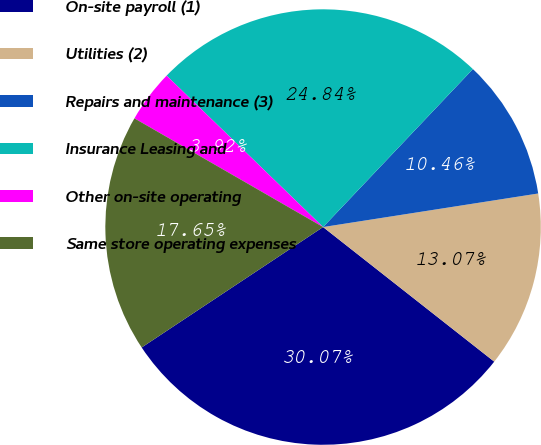Convert chart. <chart><loc_0><loc_0><loc_500><loc_500><pie_chart><fcel>On-site payroll (1)<fcel>Utilities (2)<fcel>Repairs and maintenance (3)<fcel>Insurance Leasing and<fcel>Other on-site operating<fcel>Same store operating expenses<nl><fcel>30.07%<fcel>13.07%<fcel>10.46%<fcel>24.84%<fcel>3.92%<fcel>17.65%<nl></chart> 